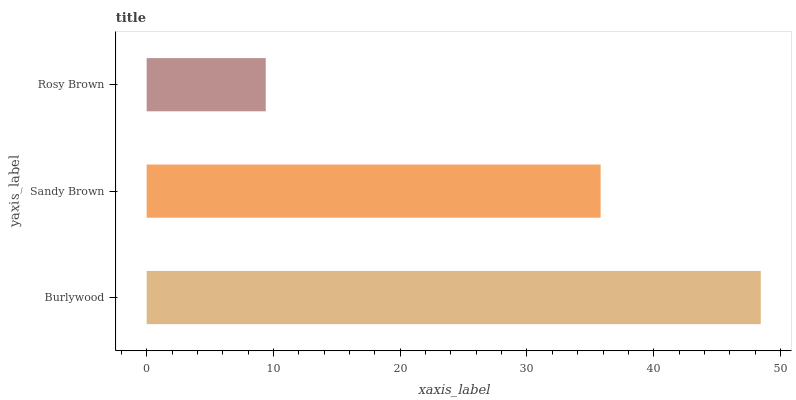Is Rosy Brown the minimum?
Answer yes or no. Yes. Is Burlywood the maximum?
Answer yes or no. Yes. Is Sandy Brown the minimum?
Answer yes or no. No. Is Sandy Brown the maximum?
Answer yes or no. No. Is Burlywood greater than Sandy Brown?
Answer yes or no. Yes. Is Sandy Brown less than Burlywood?
Answer yes or no. Yes. Is Sandy Brown greater than Burlywood?
Answer yes or no. No. Is Burlywood less than Sandy Brown?
Answer yes or no. No. Is Sandy Brown the high median?
Answer yes or no. Yes. Is Sandy Brown the low median?
Answer yes or no. Yes. Is Rosy Brown the high median?
Answer yes or no. No. Is Burlywood the low median?
Answer yes or no. No. 